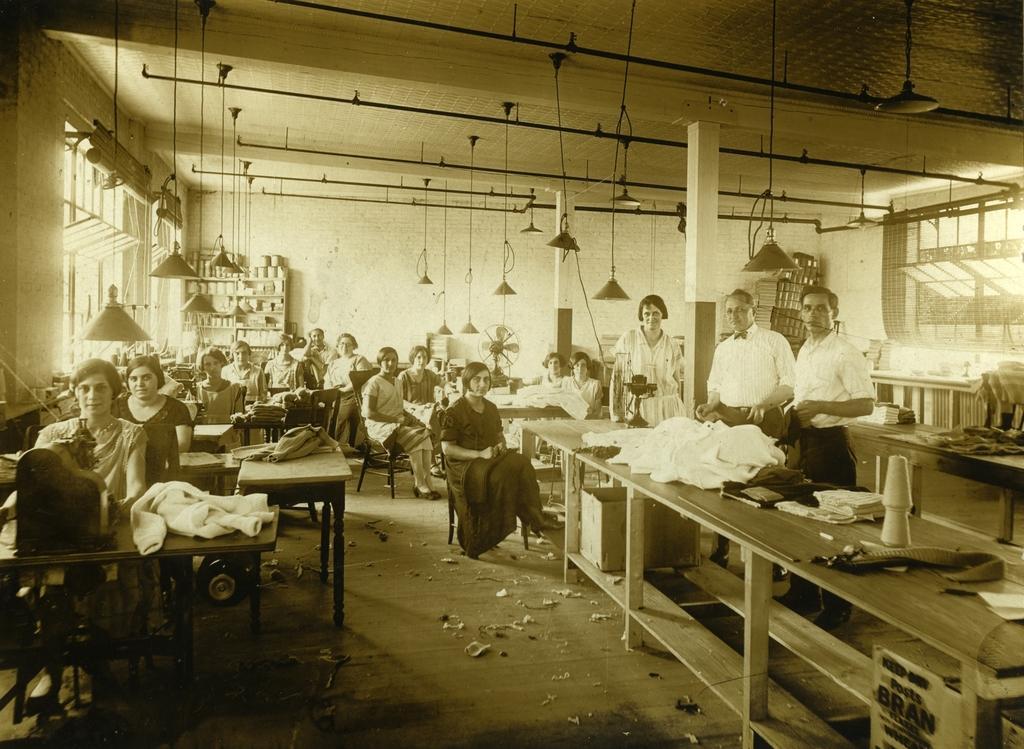How would you summarize this image in a sentence or two? In this image there are group of people sitting, three personś standing, there are tables, there is cloth on the table, there are pillars,they lightś are hanging from the roof,there are windowś, there is a wall. 